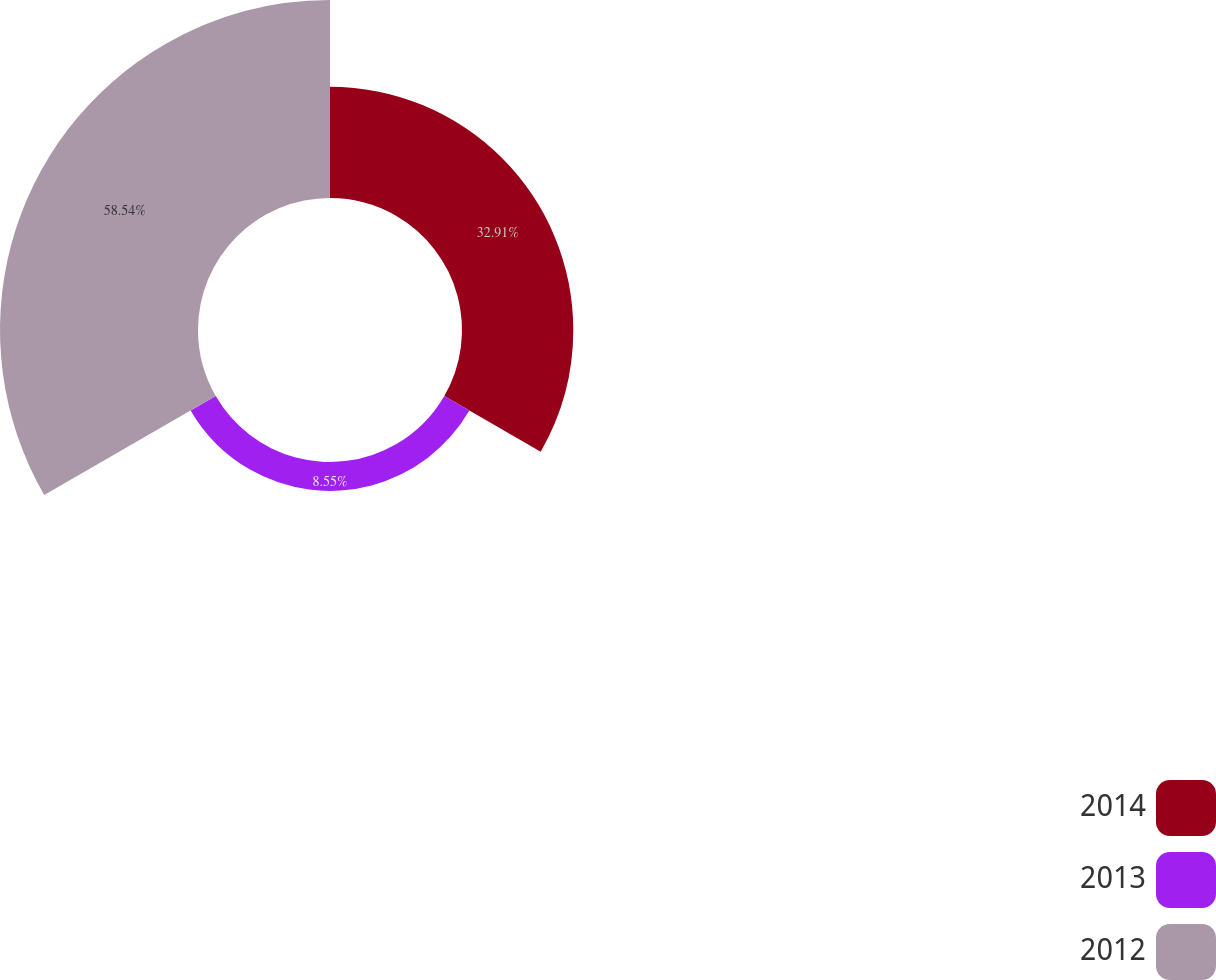Convert chart to OTSL. <chart><loc_0><loc_0><loc_500><loc_500><pie_chart><fcel>2014<fcel>2013<fcel>2012<nl><fcel>32.91%<fcel>8.55%<fcel>58.55%<nl></chart> 